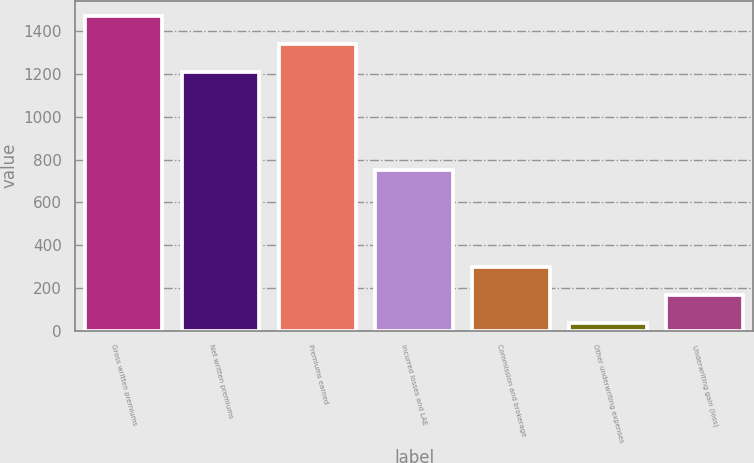Convert chart to OTSL. <chart><loc_0><loc_0><loc_500><loc_500><bar_chart><fcel>Gross written premiums<fcel>Net written premiums<fcel>Premiums earned<fcel>Incurred losses and LAE<fcel>Commission and brokerage<fcel>Other underwriting expenses<fcel>Underwriting gain (loss)<nl><fcel>1468.98<fcel>1209<fcel>1338.99<fcel>749.9<fcel>298.69<fcel>34.3<fcel>168.7<nl></chart> 